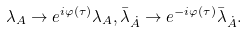Convert formula to latex. <formula><loc_0><loc_0><loc_500><loc_500>\lambda _ { A } \rightarrow e ^ { i \varphi ( \tau ) } \lambda _ { A } , \bar { \lambda } _ { \dot { A } } \rightarrow e ^ { - i \varphi ( \tau ) } \bar { \lambda } _ { \dot { A } } .</formula> 